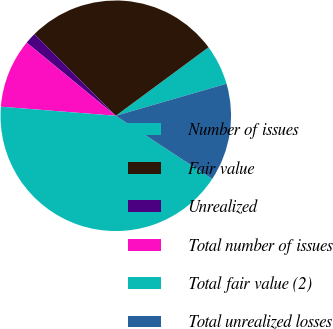<chart> <loc_0><loc_0><loc_500><loc_500><pie_chart><fcel>Number of issues<fcel>Fair value<fcel>Unrealized<fcel>Total number of issues<fcel>Total fair value (2)<fcel>Total unrealized losses<nl><fcel>5.64%<fcel>27.35%<fcel>1.59%<fcel>9.68%<fcel>42.02%<fcel>13.72%<nl></chart> 